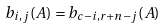<formula> <loc_0><loc_0><loc_500><loc_500>b _ { i , j } ( A ) = b _ { c - i , r + n - j } ( A )</formula> 